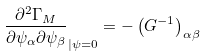Convert formula to latex. <formula><loc_0><loc_0><loc_500><loc_500>\frac { \partial ^ { 2 } \Gamma _ { M } } { \partial \psi _ { \alpha } \partial \psi _ { \beta } } _ { | \psi = 0 } = - \left ( G ^ { - 1 } \right ) _ { \alpha \beta }</formula> 